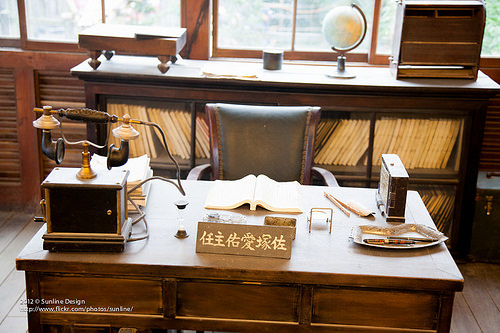<image>
Can you confirm if the book is on the desk? No. The book is not positioned on the desk. They may be near each other, but the book is not supported by or resting on top of the desk. 